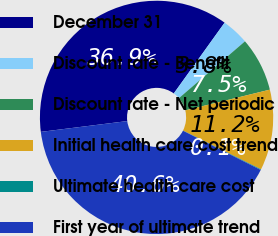Convert chart to OTSL. <chart><loc_0><loc_0><loc_500><loc_500><pie_chart><fcel>December 31<fcel>Discount rate - Benefit<fcel>Discount rate - Net periodic<fcel>Initial health care cost trend<fcel>Ultimate health care cost<fcel>First year of ultimate trend<nl><fcel>36.89%<fcel>3.78%<fcel>7.48%<fcel>11.17%<fcel>0.09%<fcel>40.58%<nl></chart> 